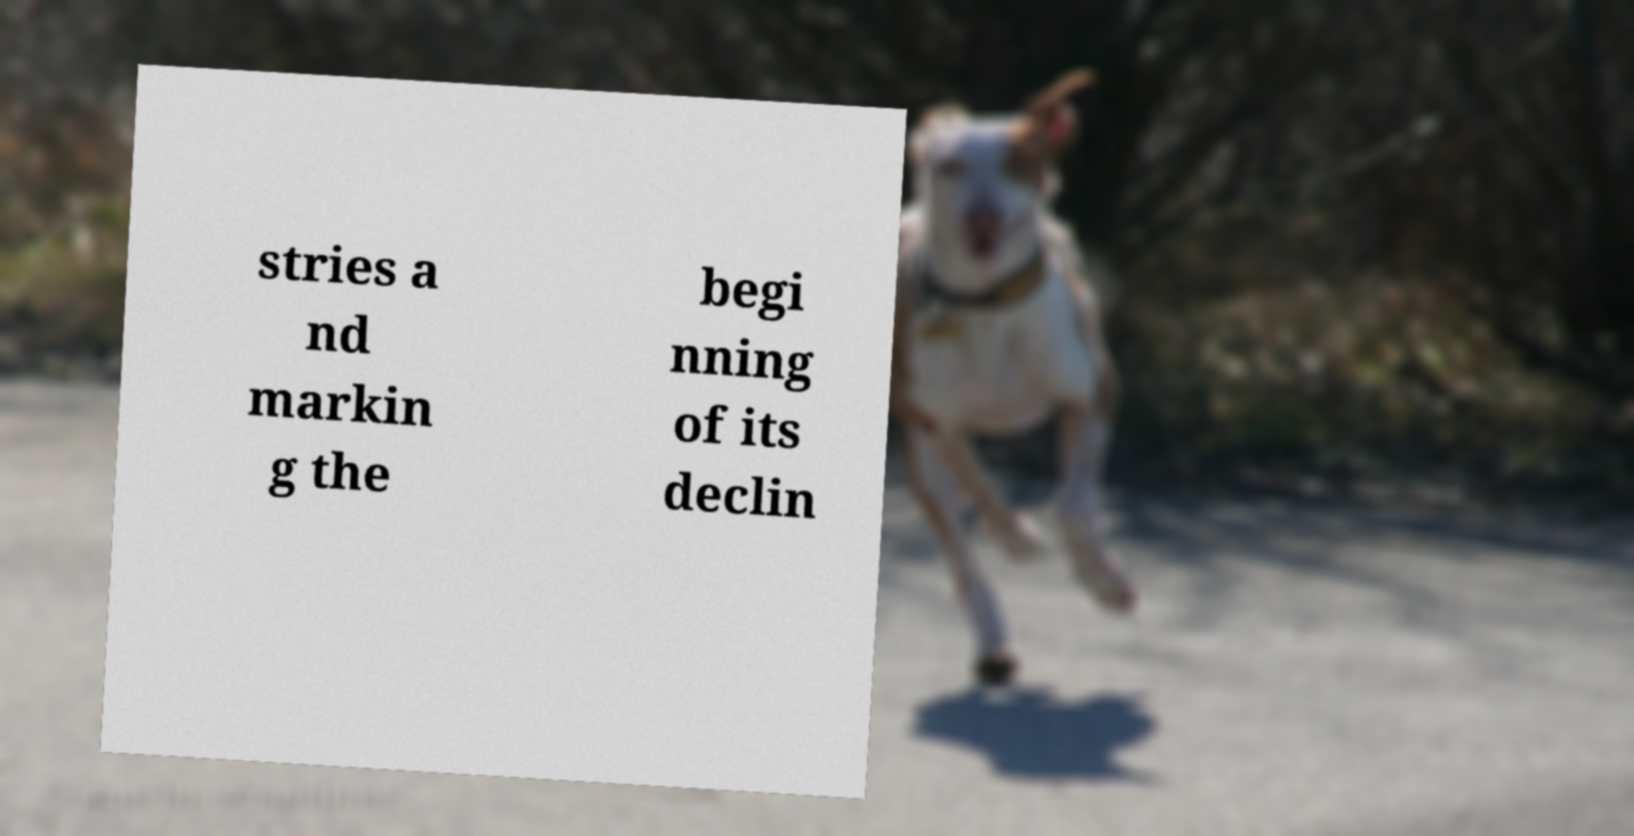Could you extract and type out the text from this image? stries a nd markin g the begi nning of its declin 